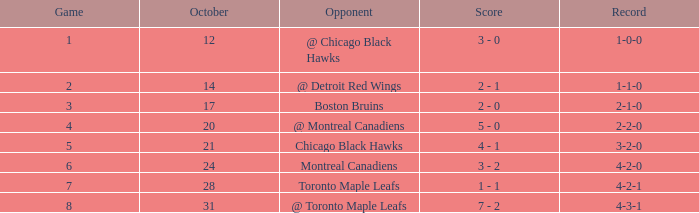What was the game's score following game 6 on october 28? 1 - 1. 